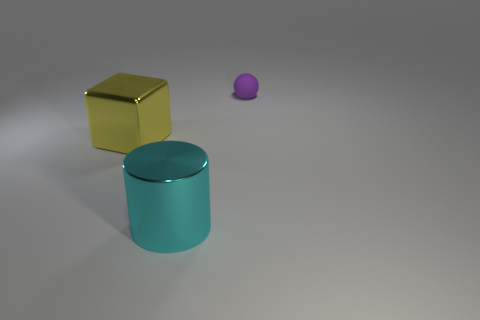Is there any other thing that has the same shape as the tiny object?
Ensure brevity in your answer.  No. Is the big yellow cube made of the same material as the thing behind the yellow thing?
Provide a succinct answer. No. How many things are to the right of the large cube and behind the cyan cylinder?
Give a very brief answer. 1. How many other things are made of the same material as the large block?
Your answer should be very brief. 1. Does the thing that is in front of the large yellow metal cube have the same material as the small purple ball?
Keep it short and to the point. No. What size is the metal thing on the left side of the object that is in front of the big metallic thing that is left of the cyan metallic object?
Ensure brevity in your answer.  Large. There is a yellow metallic thing that is the same size as the cyan metallic object; what is its shape?
Offer a terse response. Cube. There is a shiny thing on the left side of the cyan metallic cylinder; how big is it?
Provide a short and direct response. Large. What is the thing that is in front of the large metallic thing to the left of the big thing in front of the block made of?
Provide a short and direct response. Metal. Are there any cylinders that have the same size as the yellow thing?
Provide a short and direct response. Yes. 